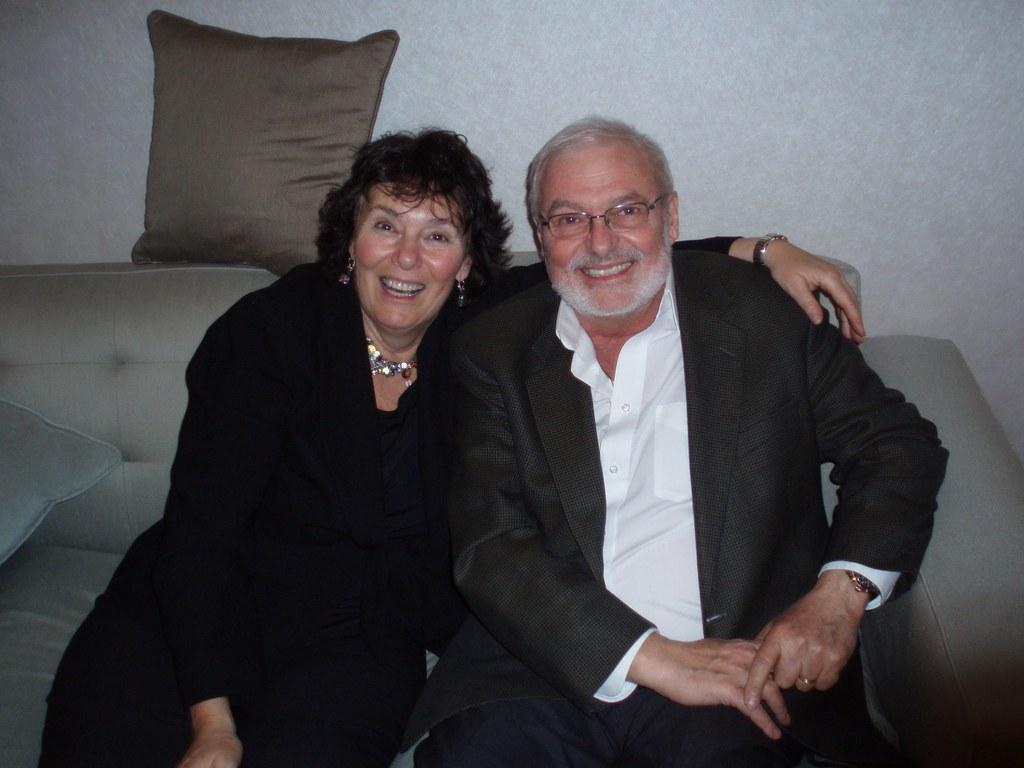How would you summarize this image in a sentence or two? In the picture two people were sitting on the sofa, they are smiling and posing for the photo. Behind the people there is a pillow and it is above the sofa. 